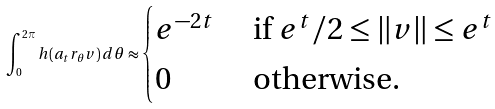Convert formula to latex. <formula><loc_0><loc_0><loc_500><loc_500>\int _ { 0 } ^ { 2 \pi } h ( a _ { t } r _ { \theta } v ) \, d \theta \approx \begin{cases} e ^ { - 2 t } & \text {   if $e^{t}/2 \leq \|v \| \leq e^{t}$ } \\ 0 & \text { otherwise} . \end{cases}</formula> 